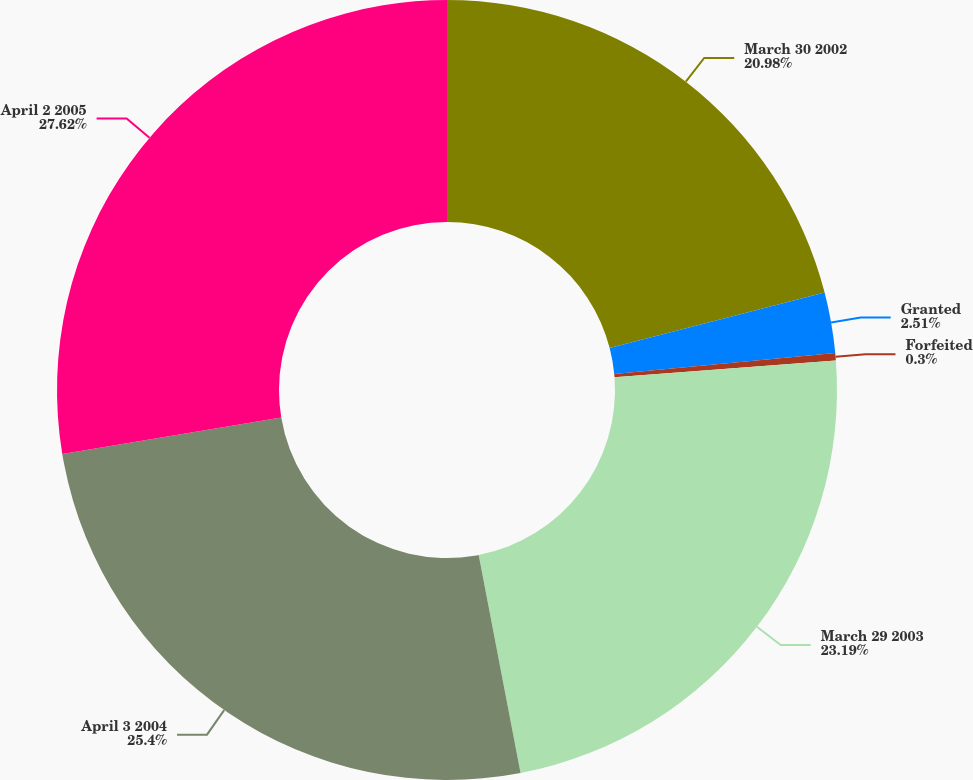Convert chart. <chart><loc_0><loc_0><loc_500><loc_500><pie_chart><fcel>March 30 2002<fcel>Granted<fcel>Forfeited<fcel>March 29 2003<fcel>April 3 2004<fcel>April 2 2005<nl><fcel>20.98%<fcel>2.51%<fcel>0.3%<fcel>23.19%<fcel>25.4%<fcel>27.62%<nl></chart> 